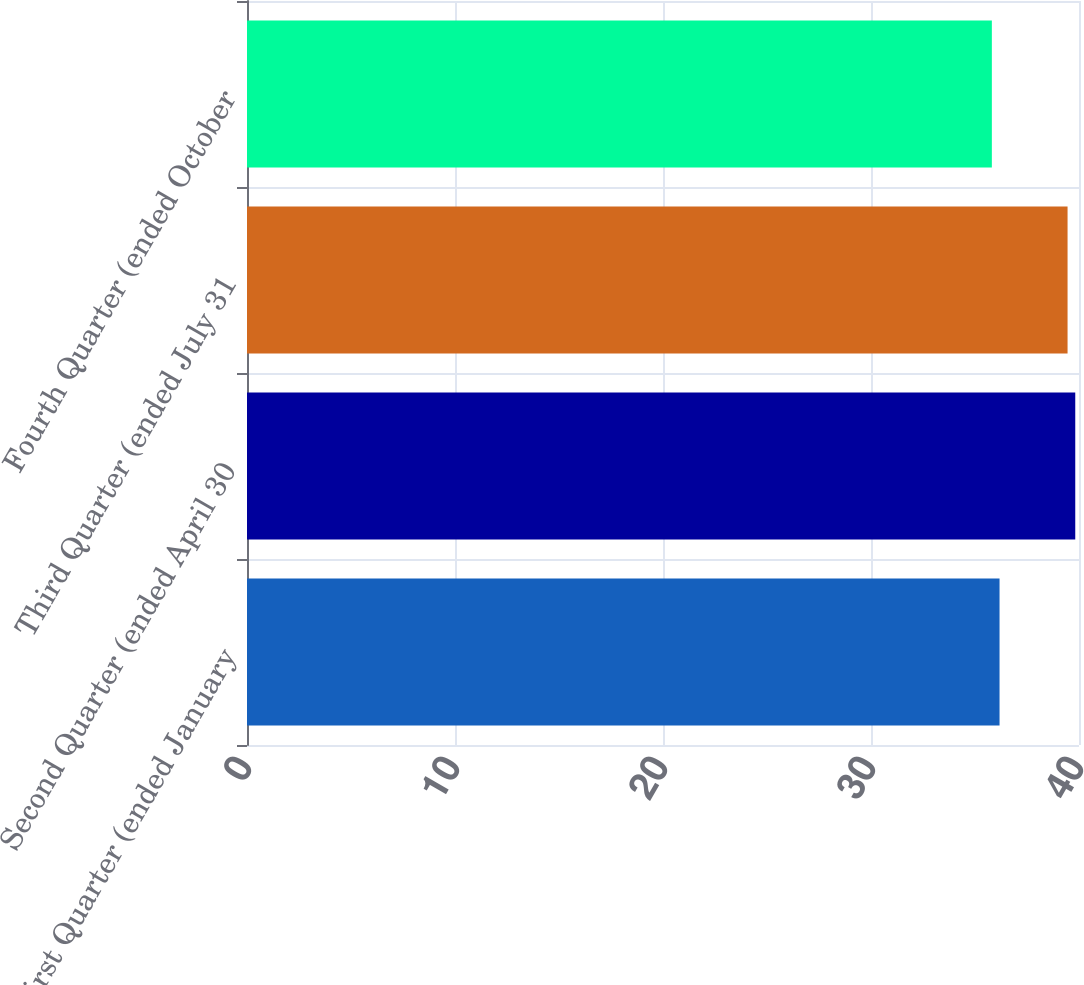<chart> <loc_0><loc_0><loc_500><loc_500><bar_chart><fcel>First Quarter (ended January<fcel>Second Quarter (ended April 30<fcel>Third Quarter (ended July 31<fcel>Fourth Quarter (ended October<nl><fcel>36.18<fcel>39.82<fcel>39.45<fcel>35.81<nl></chart> 